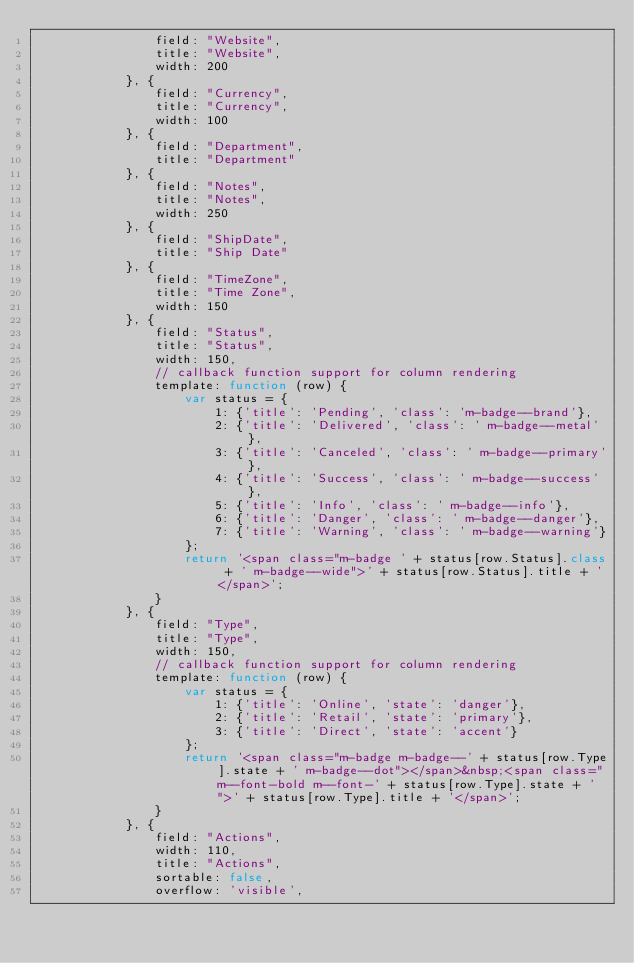Convert code to text. <code><loc_0><loc_0><loc_500><loc_500><_JavaScript_>				field: "Website",
				title: "Website",
				width: 200
			}, {
				field: "Currency",
				title: "Currency",
				width: 100
			}, {
				field: "Department",
				title: "Department"
			}, {
				field: "Notes",
				title: "Notes",
				width: 250
			}, {
				field: "ShipDate",
				title: "Ship Date"
			}, {
				field: "TimeZone",
				title: "Time Zone",
				width: 150
			}, {
				field: "Status",
				title: "Status",
				width: 150,
				// callback function support for column rendering
				template: function (row) {
					var status = {
						1: {'title': 'Pending', 'class': 'm-badge--brand'},
						2: {'title': 'Delivered', 'class': ' m-badge--metal'},
						3: {'title': 'Canceled', 'class': ' m-badge--primary'},
						4: {'title': 'Success', 'class': ' m-badge--success'},
						5: {'title': 'Info', 'class': ' m-badge--info'},
						6: {'title': 'Danger', 'class': ' m-badge--danger'},
						7: {'title': 'Warning', 'class': ' m-badge--warning'}
					};
					return '<span class="m-badge ' + status[row.Status].class + ' m-badge--wide">' + status[row.Status].title + '</span>';
				}
			}, {
				field: "Type",
				title: "Type",
				width: 150,
				// callback function support for column rendering
				template: function (row) {
					var status = {
						1: {'title': 'Online', 'state': 'danger'},
						2: {'title': 'Retail', 'state': 'primary'},
						3: {'title': 'Direct', 'state': 'accent'}
					};
					return '<span class="m-badge m-badge--' + status[row.Type].state + ' m-badge--dot"></span>&nbsp;<span class="m--font-bold m--font-' + status[row.Type].state + '">' + status[row.Type].title + '</span>';
				}
			}, {
				field: "Actions",
				width: 110,
				title: "Actions",
				sortable: false,
				overflow: 'visible',</code> 